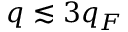<formula> <loc_0><loc_0><loc_500><loc_500>q \lesssim 3 q _ { F }</formula> 